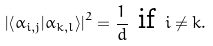<formula> <loc_0><loc_0><loc_500><loc_500>\left | \left \langle \alpha _ { i , j } | \alpha _ { k , l } \right \rangle \right | ^ { 2 } = \frac { 1 } { d } \text { if } i \neq k .</formula> 